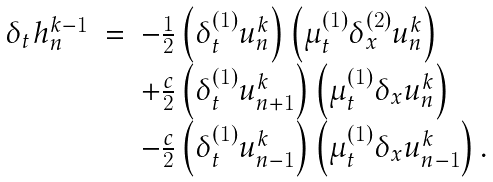Convert formula to latex. <formula><loc_0><loc_0><loc_500><loc_500>\begin{array} { r c l } \delta _ { t } h _ { n } ^ { k - 1 } & = & - \frac { 1 } { 2 } \left ( \delta _ { t } ^ { ( 1 ) } u _ { n } ^ { k } \right ) \left ( \mu _ { t } ^ { ( 1 ) } \delta _ { x } ^ { ( 2 ) } u _ { n } ^ { k } \right ) \\ & & + \frac { c } { 2 } \left ( \delta _ { t } ^ { ( 1 ) } u _ { n + 1 } ^ { k } \right ) \left ( \mu _ { t } ^ { ( 1 ) } \delta _ { x } u _ { n } ^ { k } \right ) \\ & & - \frac { c } { 2 } \left ( \delta _ { t } ^ { ( 1 ) } u _ { n - 1 } ^ { k } \right ) \left ( \mu _ { t } ^ { ( 1 ) } \delta _ { x } u _ { n - 1 } ^ { k } \right ) . \end{array}</formula> 